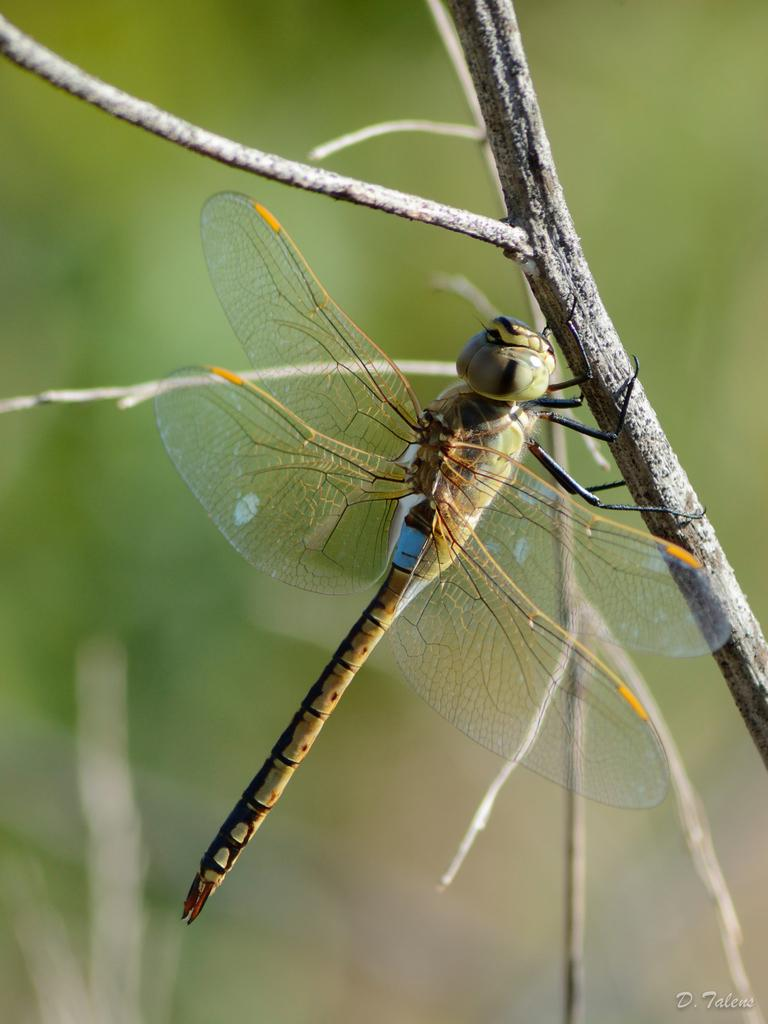What can be observed about the background of the image? The background of the image is blurred. What type of natural elements are present in the image? There are twigs in the image. What is the dragonfly doing with the twig? A dragonfly is holding a twig in the image. How many quarters can be seen in the image? There are no quarters present in the image. What type of leather material is visible in the image? There is no leather material visible in the image. 